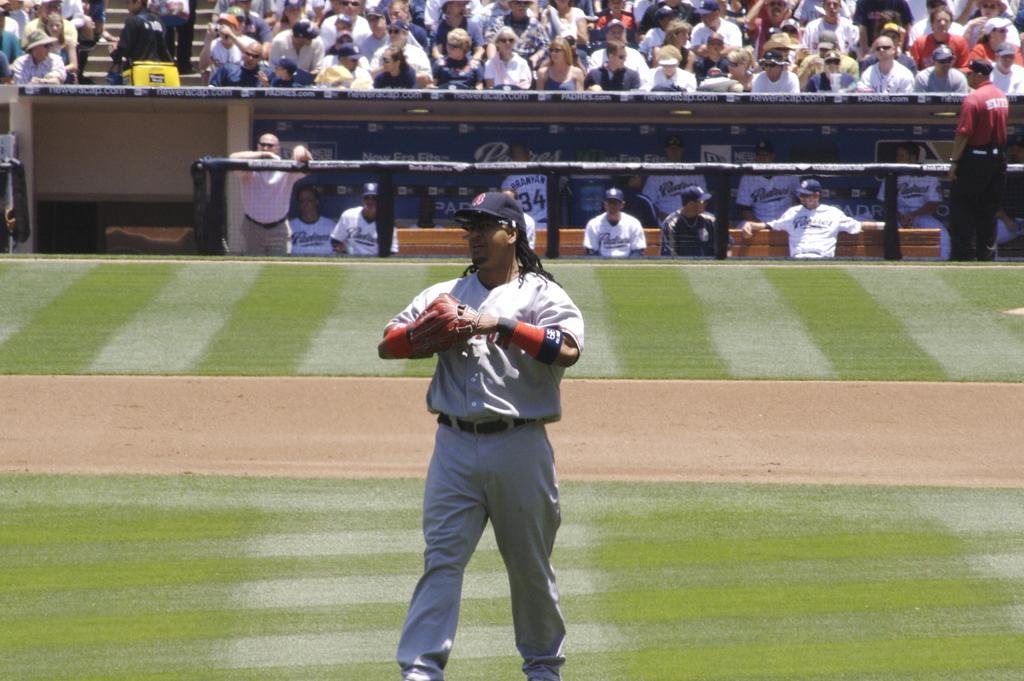Describe this image in one or two sentences. In the center of the image we can see a man standing. He is wearing a cap. In the background there is crowd sitting and we can see people. There is a board. 